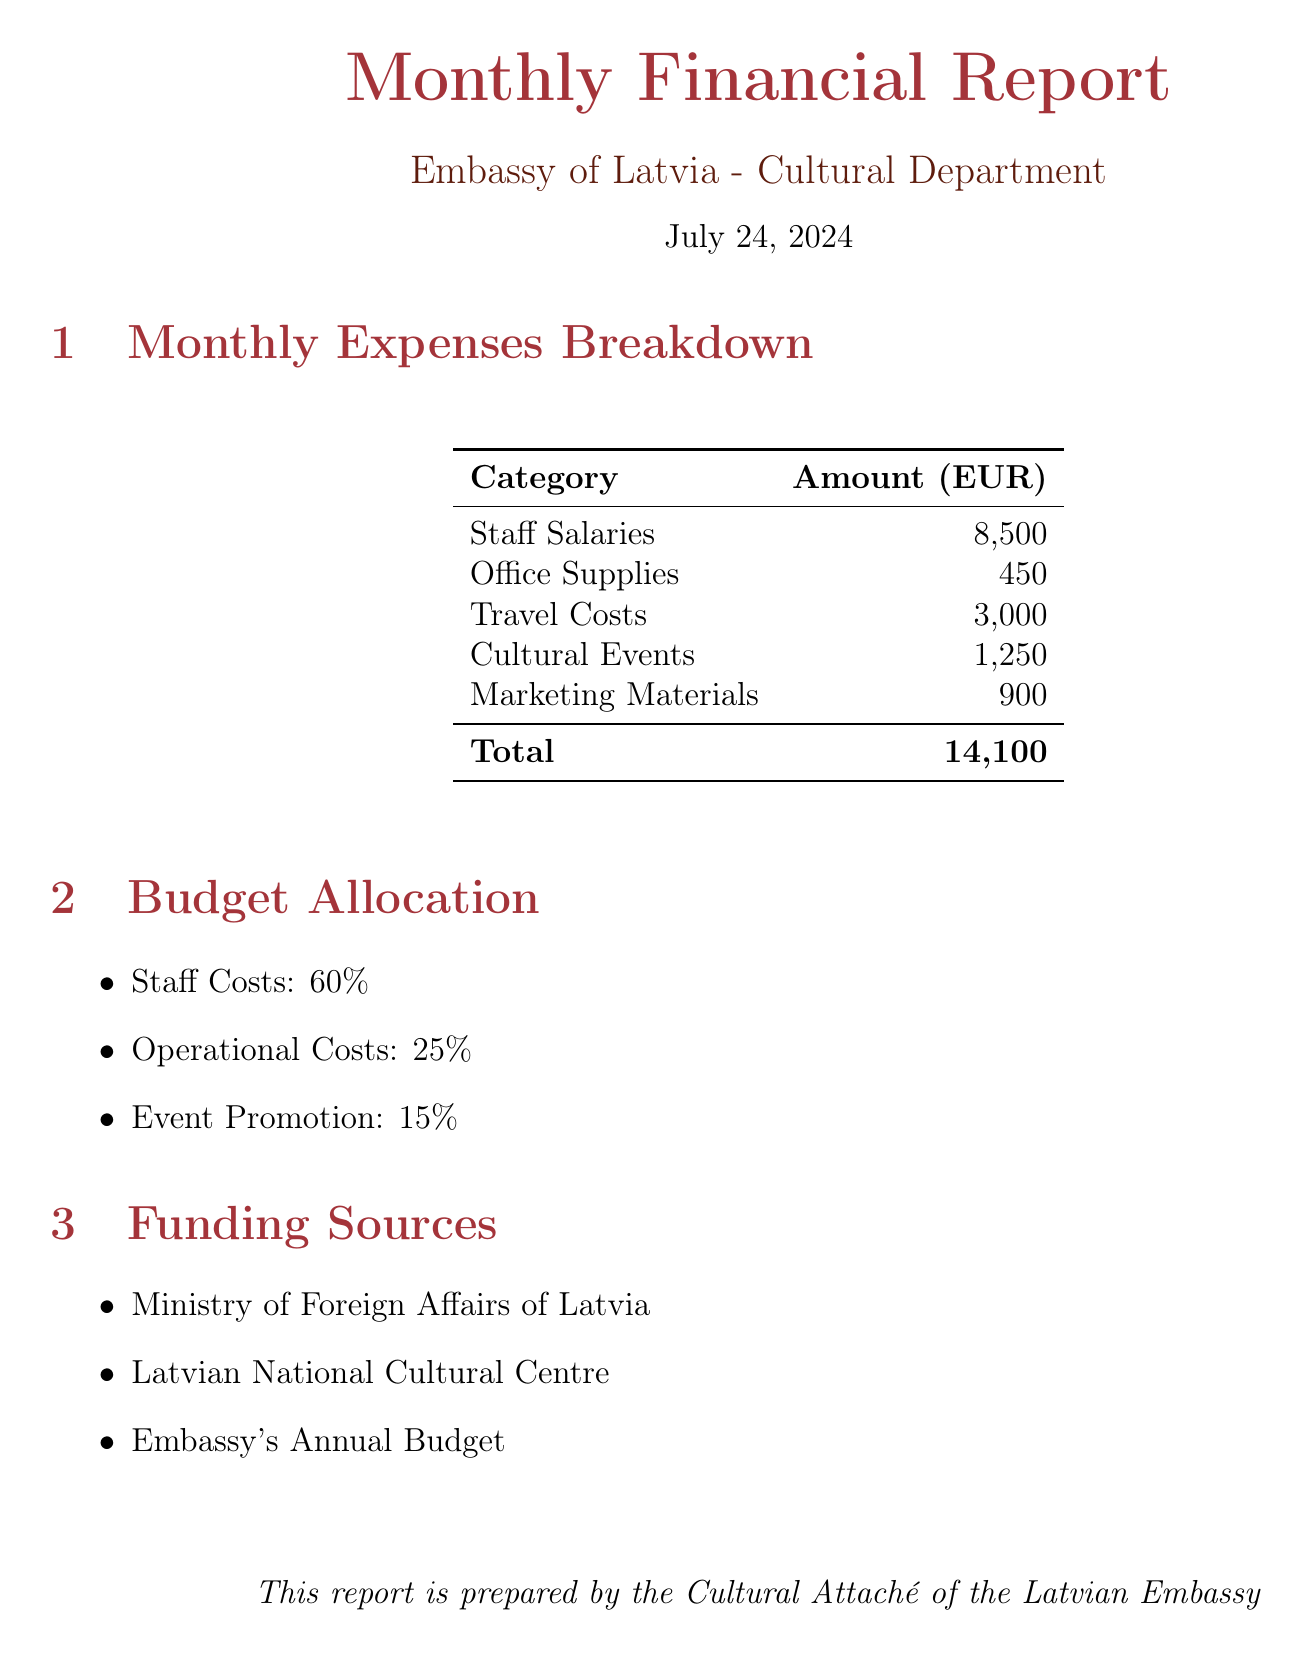What is the total amount of monthly expenses? The total amount of monthly expenses is specified at the bottom of the expenses breakdown section of the document.
Answer: 14,100 What is the staff salary for the Cultural Affairs Officer? The salary for the Cultural Affairs Officer is listed under staff salaries.
Answer: 3,500 How much is allocated to travel costs? The travel costs are detailed in the monthly expenses section.
Answer: 3,000 What percentage of the budget is designated for staff costs? The budget allocation section specifies the percentage for staff costs.
Answer: 60% What is the cost of printing paper? The cost of printing paper is indicated in the office supplies section.
Answer: 120 What is the total cost for cultural events? The total cost for cultural events is the sum of the individual event costs listed in the document.
Answer: 1,250 Which conference has a travel cost of 1,800? The travel costs to various destinations are listed, and the specific conference with this cost can be identified.
Answer: UNESCO Conference, Paris What is the funding source from Latvia's Ministry? The funding sources section provides the names of the funding organizations, including the one from the Ministry.
Answer: Ministry of Foreign Affairs of Latvia How much was spent on office supplies? The total expenses for office supplies are detailed in the expenses breakdown table.
Answer: 450 